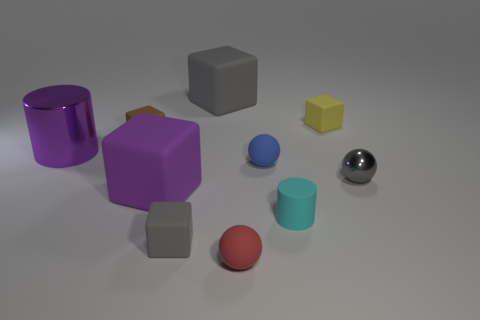Subtract 1 cubes. How many cubes are left? 4 Subtract all purple blocks. How many blocks are left? 4 Subtract all purple cubes. How many cubes are left? 4 Subtract all brown blocks. Subtract all green spheres. How many blocks are left? 4 Subtract all balls. How many objects are left? 7 Subtract all purple shiny cylinders. Subtract all large green metallic cylinders. How many objects are left? 9 Add 3 tiny gray blocks. How many tiny gray blocks are left? 4 Add 5 tiny purple shiny blocks. How many tiny purple shiny blocks exist? 5 Subtract 1 yellow cubes. How many objects are left? 9 